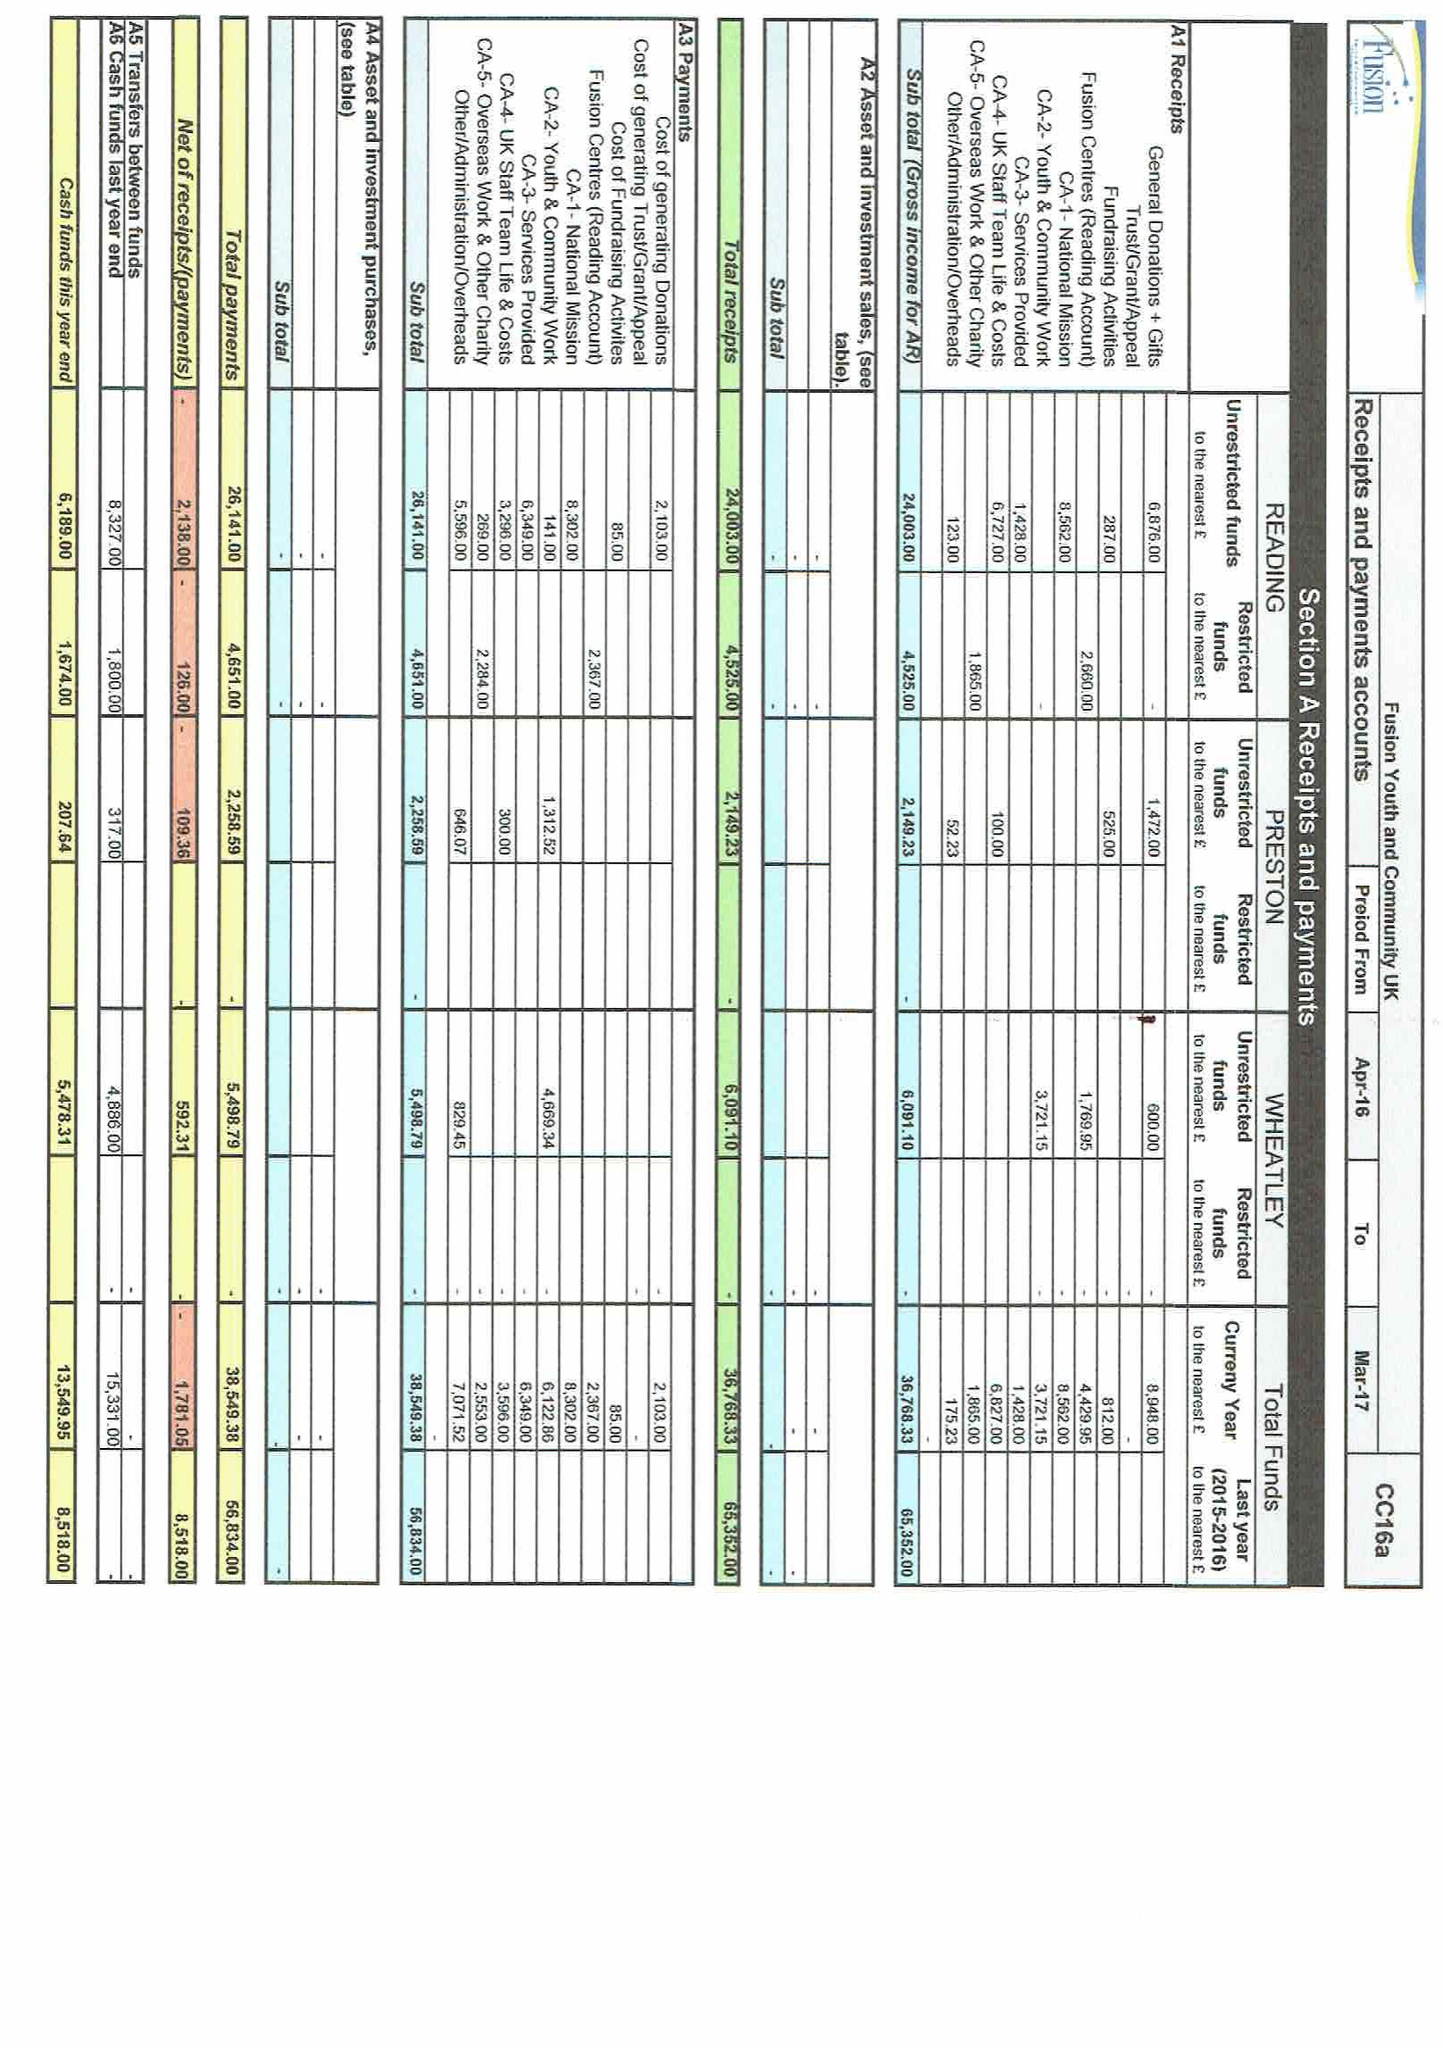What is the value for the income_annually_in_british_pounds?
Answer the question using a single word or phrase. 36768.00 